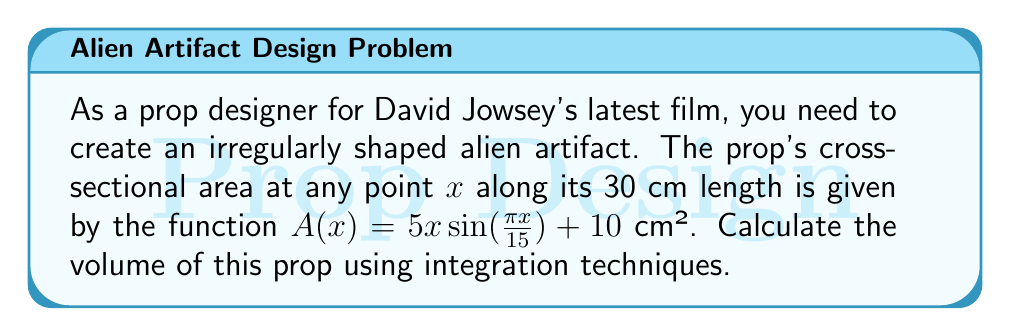Show me your answer to this math problem. To find the volume of this irregularly shaped prop, we need to use the integration technique for volumes of solids with known cross-sections. The general formula is:

$$V = \int_a^b A(x) dx$$

Where $A(x)$ is the cross-sectional area function, and $a$ and $b$ are the limits of integration.

Given:
- Length of the prop: 30 cm
- Cross-sectional area function: $A(x) = 5x\sin(\frac{\pi x}{15}) + 10$ cm²
- Limits of integration: $a = 0$, $b = 30$

Step 1: Set up the integral
$$V = \int_0^{30} (5x\sin(\frac{\pi x}{15}) + 10) dx$$

Step 2: Integrate the function
We need to integrate this function by parts. Let:
$u = x$ and $dv = 5\sin(\frac{\pi x}{15})dx$

Then:
$du = dx$ and $v = -\frac{75}{\pi}\cos(\frac{\pi x}{15})$

Using the integration by parts formula:
$$\int u dv = uv - \int v du$$

We get:
$$V = [-\frac{75x}{\pi}\cos(\frac{\pi x}{15}) + \frac{1125}{\pi^2}\sin(\frac{\pi x}{15})]_0^{30} + 10x|_0^{30}$$

Step 3: Evaluate the integral
$$V = [-\frac{75(30)}{\pi}\cos(\frac{\pi(30)}{15}) + \frac{1125}{\pi^2}\sin(\frac{\pi(30)}{15}) + 300] - [-\frac{75(0)}{\pi}\cos(\frac{\pi(0)}{15}) + \frac{1125}{\pi^2}\sin(\frac{\pi(0)}{15}) + 0]$$

$$V = [\frac{2250}{\pi} + 300] - [0]$$

$$V = \frac{2250}{\pi} + 300 \approx 1016.2 \text{ cm}^3$$
Answer: $1016.2 \text{ cm}^3$ 